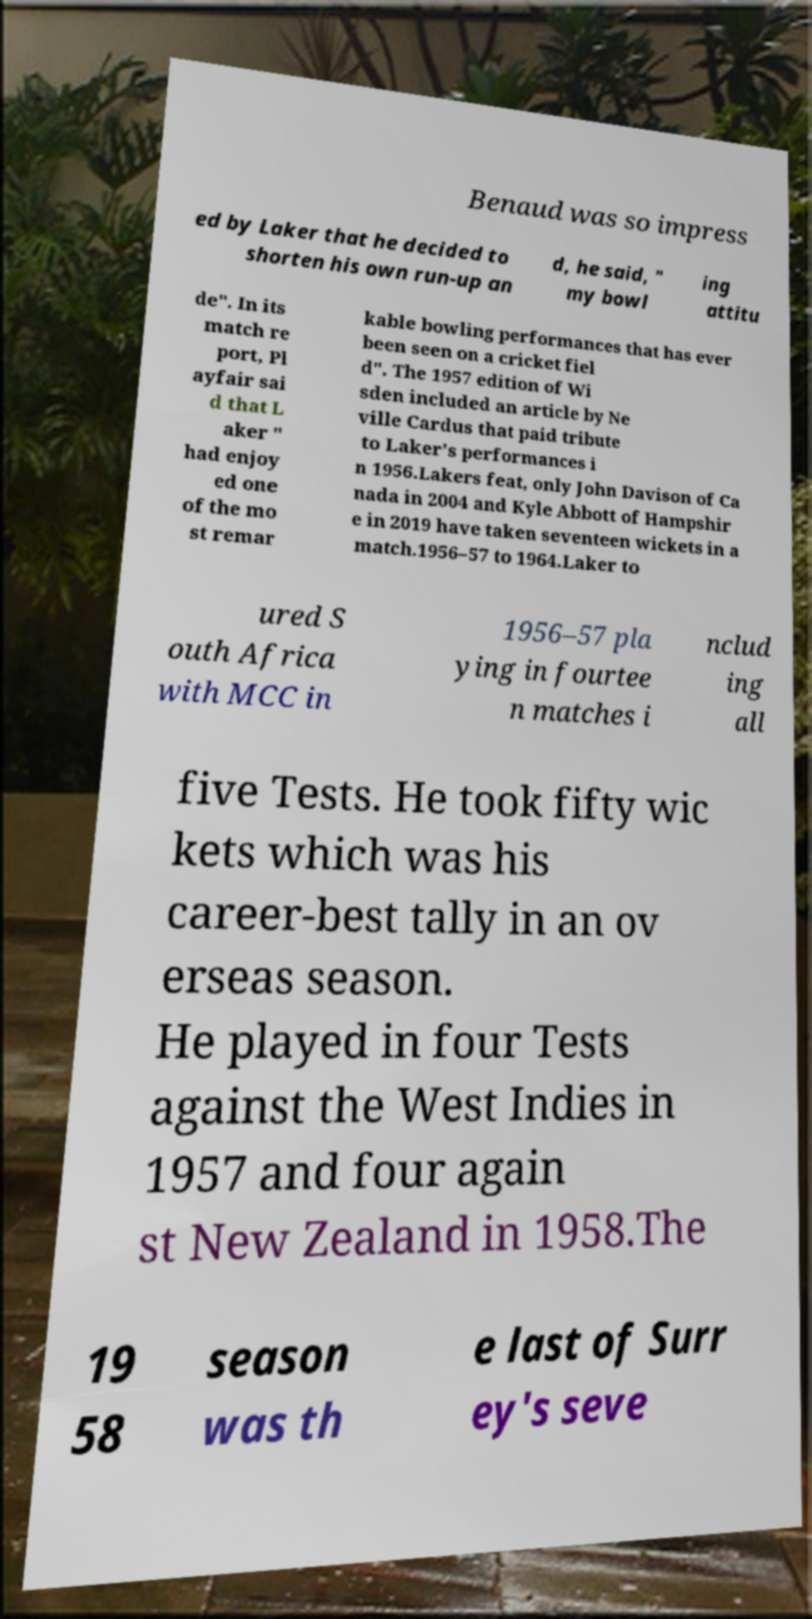Could you assist in decoding the text presented in this image and type it out clearly? Benaud was so impress ed by Laker that he decided to shorten his own run-up an d, he said, " my bowl ing attitu de". In its match re port, Pl ayfair sai d that L aker " had enjoy ed one of the mo st remar kable bowling performances that has ever been seen on a cricket fiel d". The 1957 edition of Wi sden included an article by Ne ville Cardus that paid tribute to Laker's performances i n 1956.Lakers feat, only John Davison of Ca nada in 2004 and Kyle Abbott of Hampshir e in 2019 have taken seventeen wickets in a match.1956–57 to 1964.Laker to ured S outh Africa with MCC in 1956–57 pla ying in fourtee n matches i nclud ing all five Tests. He took fifty wic kets which was his career-best tally in an ov erseas season. He played in four Tests against the West Indies in 1957 and four again st New Zealand in 1958.The 19 58 season was th e last of Surr ey's seve 